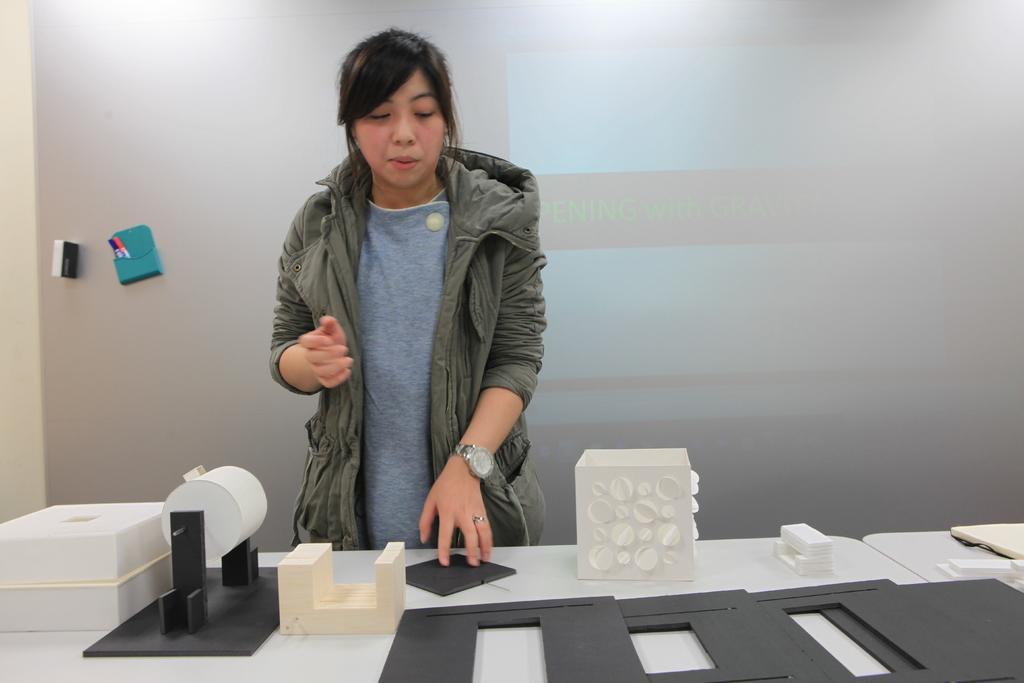Could you give a brief overview of what you see in this image? This is a room and here is a woman standing she is wearing a jacket and watch to her left hand. There is a table in front of the woman which has some gadgets on it. Behind the woman there is a projector and left to the projector there are some marks behind it there is a wall. 